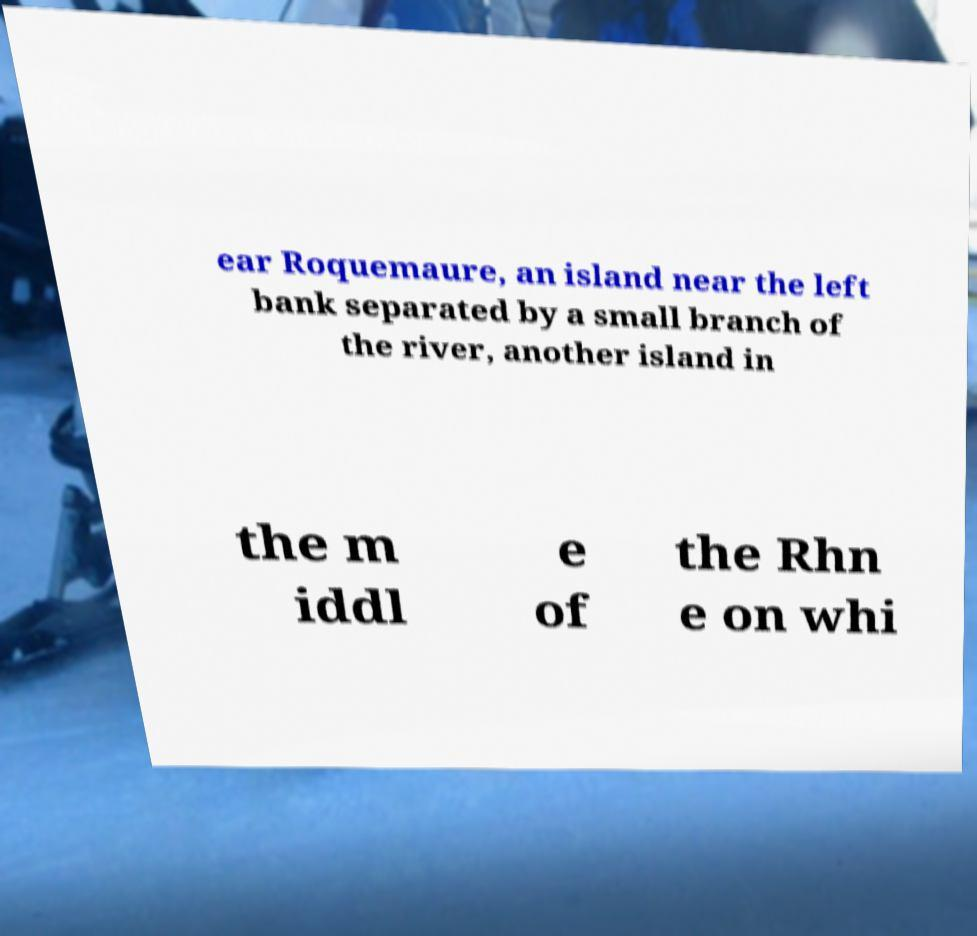What messages or text are displayed in this image? I need them in a readable, typed format. ear Roquemaure, an island near the left bank separated by a small branch of the river, another island in the m iddl e of the Rhn e on whi 